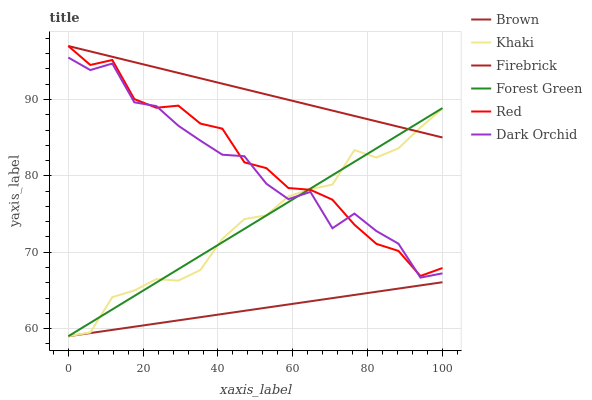Does Brown have the minimum area under the curve?
Answer yes or no. Yes. Does Firebrick have the maximum area under the curve?
Answer yes or no. Yes. Does Khaki have the minimum area under the curve?
Answer yes or no. No. Does Khaki have the maximum area under the curve?
Answer yes or no. No. Is Forest Green the smoothest?
Answer yes or no. Yes. Is Dark Orchid the roughest?
Answer yes or no. Yes. Is Khaki the smoothest?
Answer yes or no. No. Is Khaki the roughest?
Answer yes or no. No. Does Brown have the lowest value?
Answer yes or no. Yes. Does Firebrick have the lowest value?
Answer yes or no. No. Does Red have the highest value?
Answer yes or no. Yes. Does Khaki have the highest value?
Answer yes or no. No. Is Dark Orchid less than Firebrick?
Answer yes or no. Yes. Is Firebrick greater than Brown?
Answer yes or no. Yes. Does Brown intersect Khaki?
Answer yes or no. Yes. Is Brown less than Khaki?
Answer yes or no. No. Is Brown greater than Khaki?
Answer yes or no. No. Does Dark Orchid intersect Firebrick?
Answer yes or no. No. 